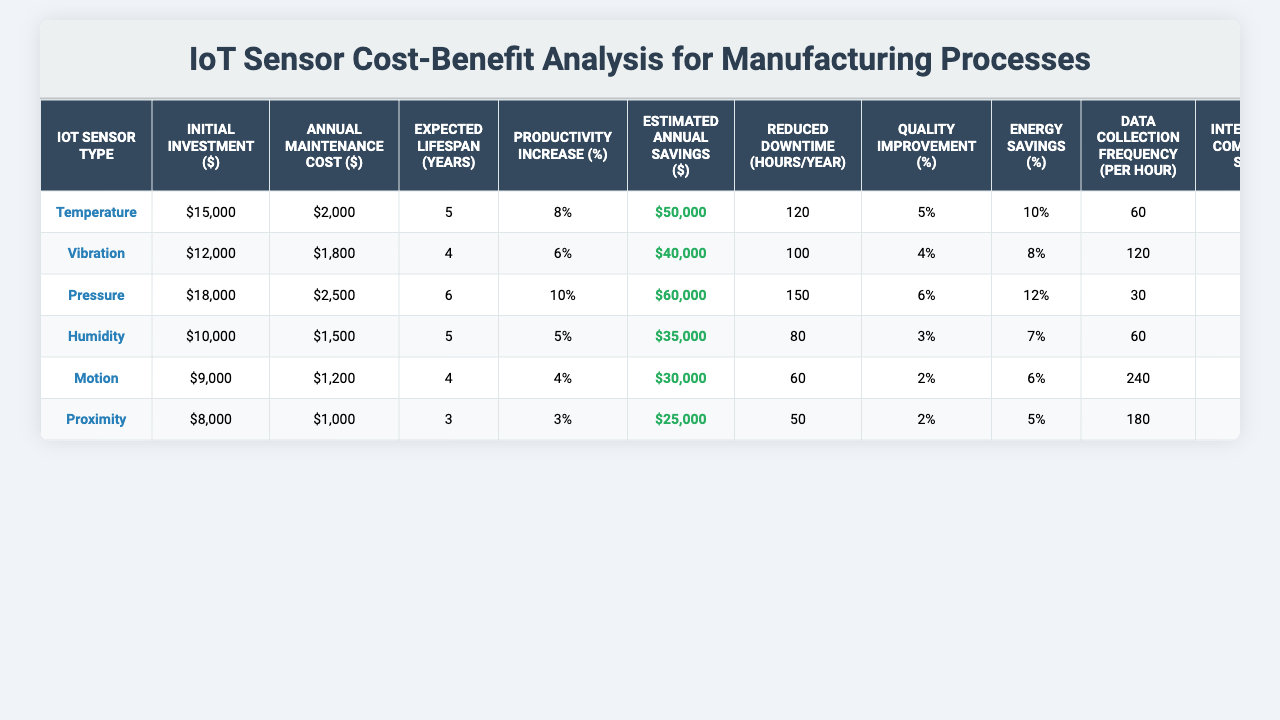What is the initial investment required for the temperature sensor? The table lists the initial investment for each IoT sensor type. For the temperature sensor, the initial investment is clearly indicated as $15,000.
Answer: $15,000 Which IoT sensor type has the highest estimated annual savings? By comparing the estimated annual savings of each sensor type in the table, the pressure sensor shows the highest value at $60,000.
Answer: Pressure sensor What is the payback period for the humidity sensor? The payback period can be found in the table under the appropriate column for the humidity sensor, which is 14 months.
Answer: 14 months Which sensor type has the lowest annual maintenance cost? Looking at the annual maintenance cost for each sensor type, the proximity sensor has the lowest cost at $1,000.
Answer: $1,000 Calculate the average expected lifespan of the sensors. To find the average expected lifespan, add the lifespan values (5 + 4 + 6 + 5 + 4 + 3 = 27) and divide by the number of sensors (27 / 6 = 4.5).
Answer: 4.5 years Which sensor type shows the lowest percentage increase in productivity? The productivity increase percentages are noted in the table, and the motion sensor has the lowest percentage at 4%.
Answer: 4% If we examine the energy savings percentage, which sensors achieve over 10% savings? By scanning through the energy savings percentages in the table, the temperature and pressure sensors exceed 10%, with 10% and 12%, respectively.
Answer: Temperature and pressure sensors How much is the total initial investment if we sum the investments for all sensor types? By adding the initial investments (15,000 + 12,000 + 18,000 + 10,000 + 9,000 + 8,000 = 72,000), the total initial investment is $72,000.
Answer: $72,000 Do any sensors require less than 25 hours of employee training? Looking through the employee training hours for each sensor, the proximity sensor requires 20 hours, which is less than 25. This confirms the sensor indeed requires less training.
Answer: Yes Which sensor has a higher integration complexity score, the temperature sensor or the vibration sensor? Checking the integration complexity scores, the temperature sensor has a score of 7 while the vibration sensor has a score of 6. The temperature sensor has a higher score.
Answer: Temperature sensor What is the difference in annual maintenance costs between the sensor with the highest and lowest costs? The highest annual maintenance cost is for the pressure sensor at $2,500, and the lowest is for the proximity sensor at $1,000. The difference is $2,500 - $1,000 = $1,500.
Answer: $1,500 Which sensor type has the most reduced downtime hours per year? Upon reviewing the reduced downtime hours, the pressure sensor stands out with the highest value of 150 hours.
Answer: Pressure sensor 